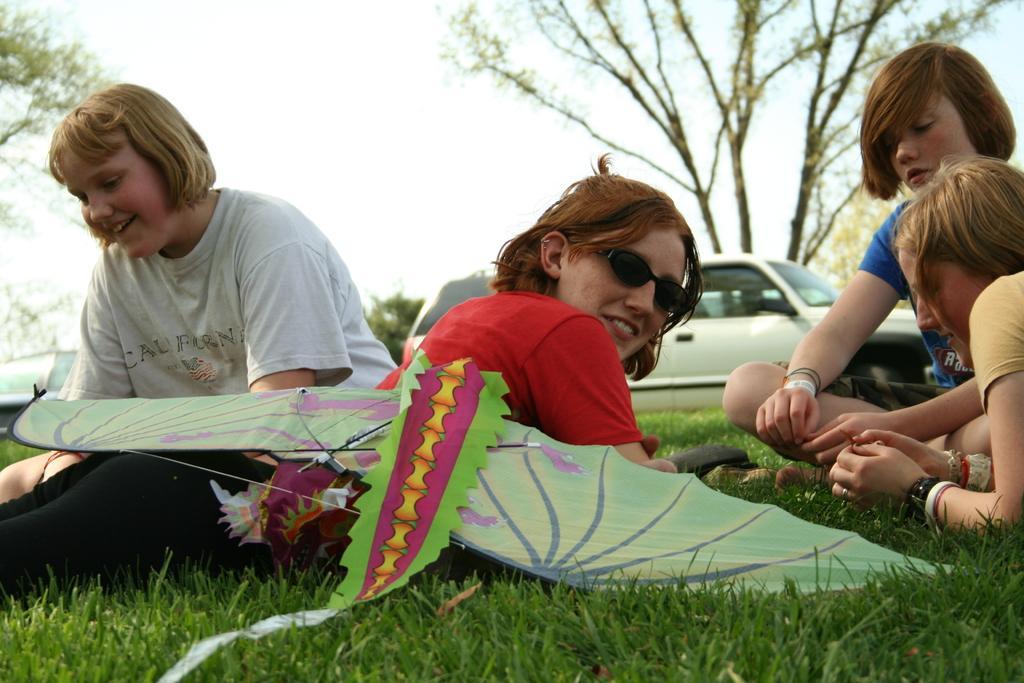In one or two sentences, can you explain what this image depicts? People are sitting on the grass. A person is lying wearing a red t shirt, black pant and goggles. There is a kite. Behind them there is a car and trees are present. 